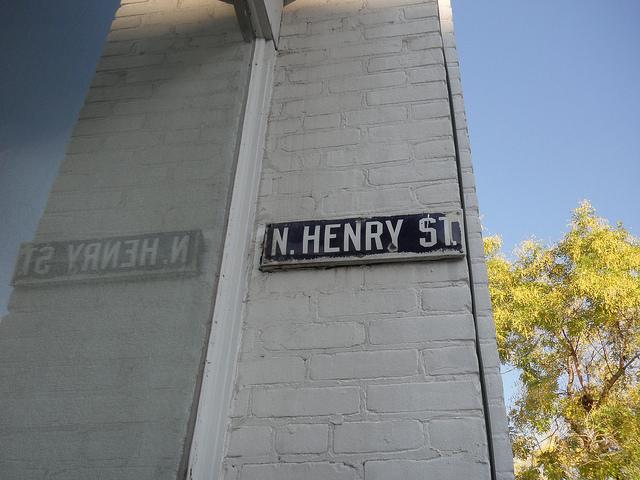What does the sign say?
Be succinct. N henry st. Is the sign reflecting on the window?
Be succinct. Yes. What is the wall made of?
Answer briefly. Brick. 